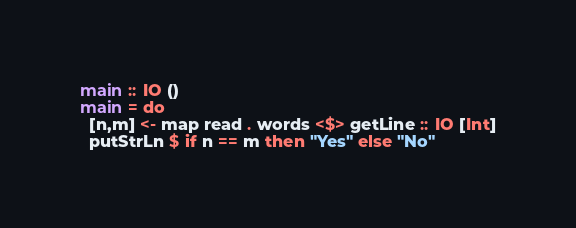Convert code to text. <code><loc_0><loc_0><loc_500><loc_500><_Haskell_>
main :: IO ()
main = do
  [n,m] <- map read . words <$> getLine :: IO [Int]
  putStrLn $ if n == m then "Yes" else "No"</code> 